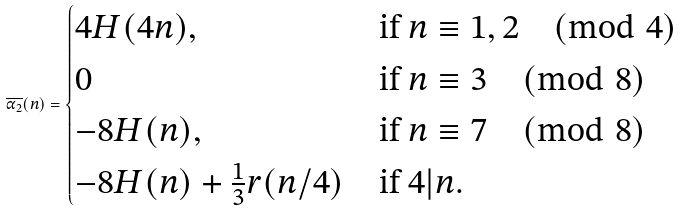Convert formula to latex. <formula><loc_0><loc_0><loc_500><loc_500>\overline { \alpha _ { 2 } } ( n ) = \begin{cases} 4 H ( 4 n ) , & \text {if } n \equiv 1 , 2 \pmod { 4 } \\ 0 & \text {if } n \equiv 3 \pmod { 8 } \\ - 8 H ( n ) , & \text {if } n \equiv 7 \pmod { 8 } \\ - 8 H ( n ) + \frac { 1 } { 3 } r ( n / 4 ) & \text {if } 4 | n . \end{cases}</formula> 